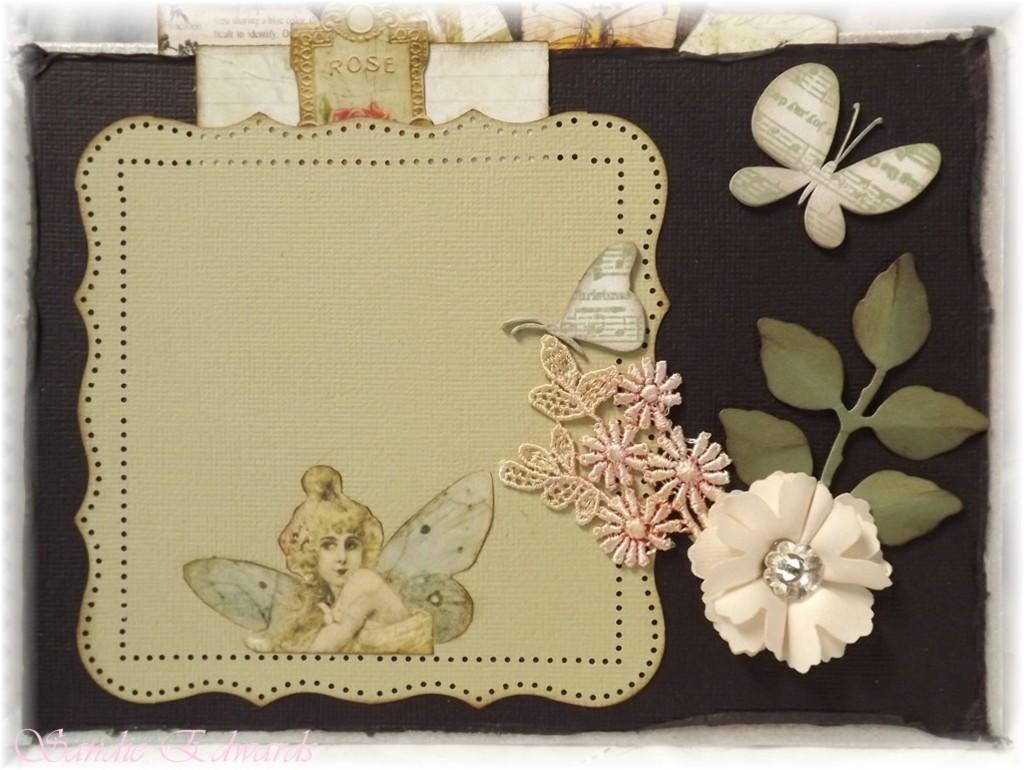Describe this image in one or two sentences. In this image there is a board, there is a cloth on the board, there are objects on the cloth, there are objects truncated towards the top of the image, there is text towards the bottom of the image. 